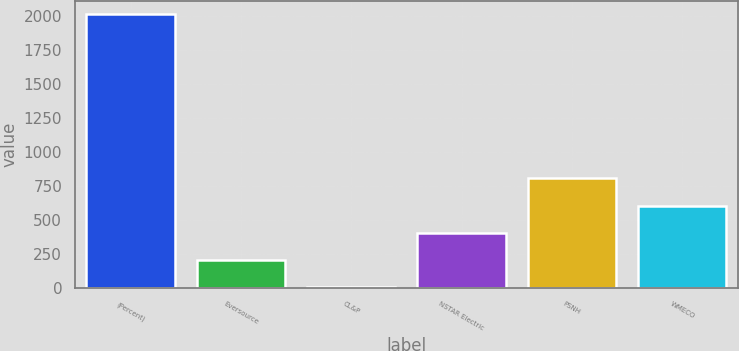Convert chart to OTSL. <chart><loc_0><loc_0><loc_500><loc_500><bar_chart><fcel>(Percent)<fcel>Eversource<fcel>CL&P<fcel>NSTAR Electric<fcel>PSNH<fcel>WMECO<nl><fcel>2013<fcel>203.55<fcel>2.5<fcel>404.6<fcel>806.7<fcel>605.65<nl></chart> 